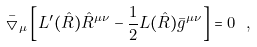<formula> <loc_0><loc_0><loc_500><loc_500>\bar { \bigtriangledown } _ { \mu } \left [ L ^ { \prime } ( \hat { R } ) \hat { R } ^ { \mu \nu } - \frac { 1 } { 2 } L ( \hat { R } ) \bar { g } ^ { \mu \nu } \right ] = 0 \ ,</formula> 